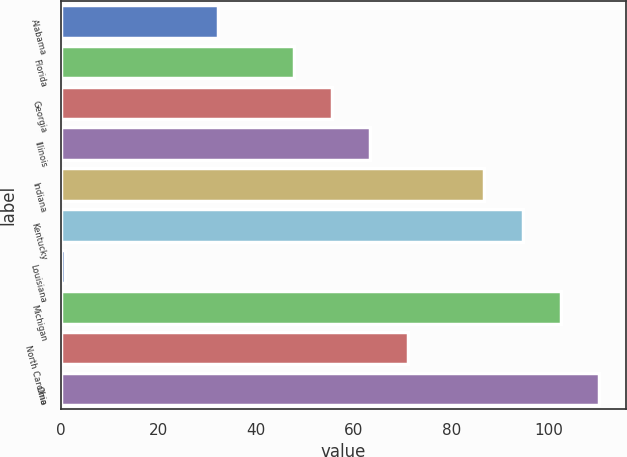Convert chart. <chart><loc_0><loc_0><loc_500><loc_500><bar_chart><fcel>Alabama<fcel>Florida<fcel>Georgia<fcel>Illinois<fcel>Indiana<fcel>Kentucky<fcel>Louisiana<fcel>Michigan<fcel>North Carolina<fcel>Ohio<nl><fcel>32.2<fcel>47.8<fcel>55.6<fcel>63.4<fcel>86.8<fcel>94.6<fcel>1<fcel>102.4<fcel>71.2<fcel>110.2<nl></chart> 